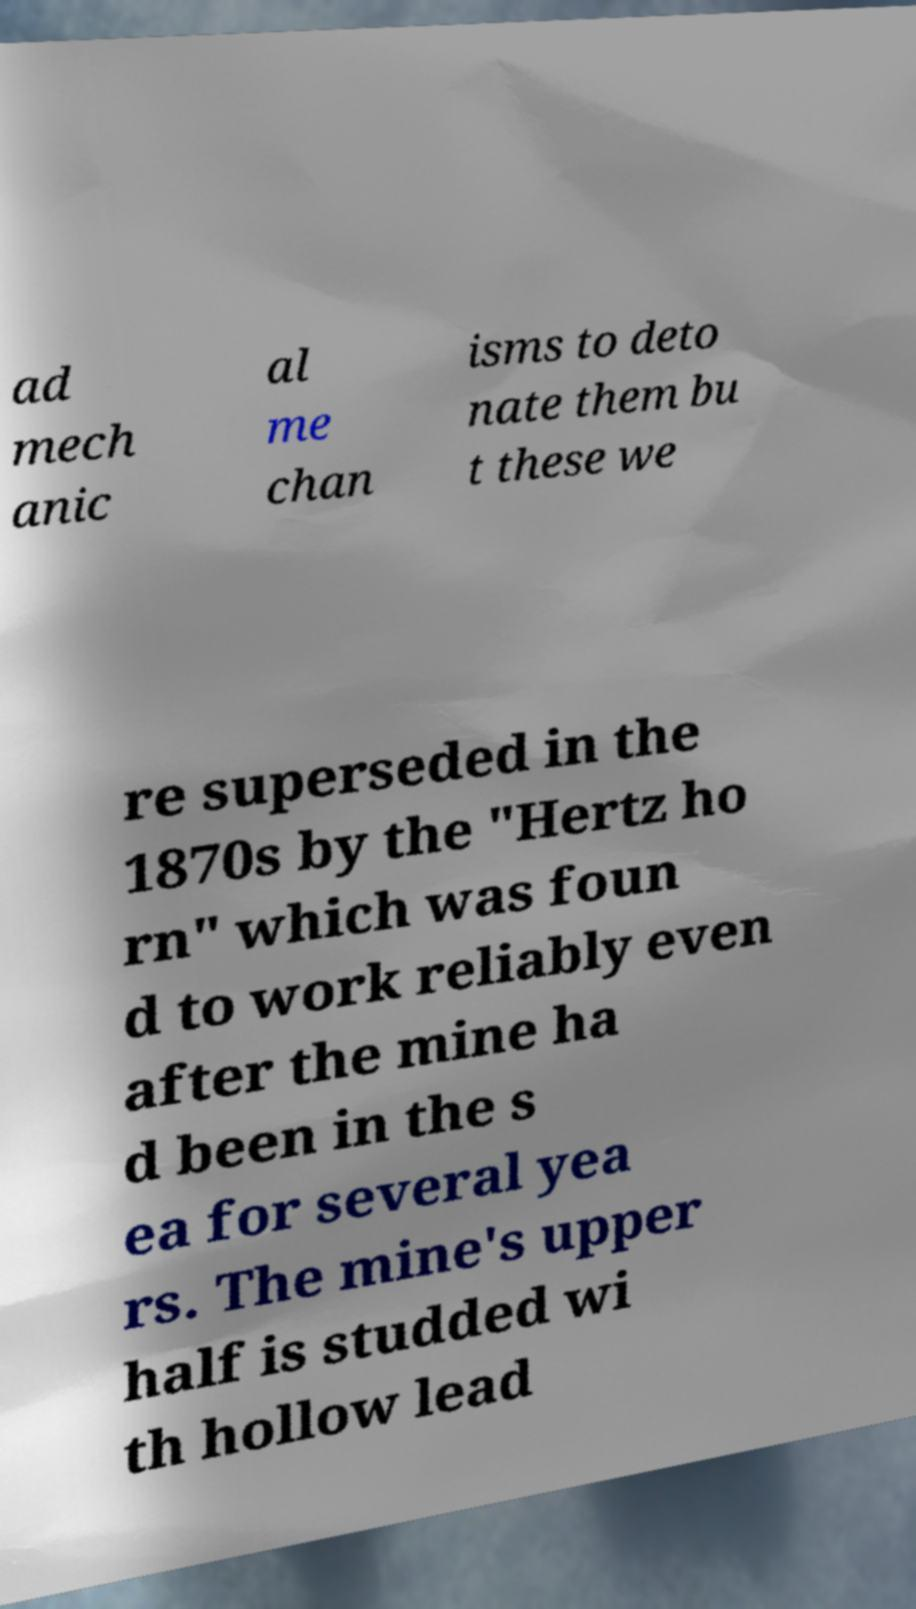I need the written content from this picture converted into text. Can you do that? ad mech anic al me chan isms to deto nate them bu t these we re superseded in the 1870s by the "Hertz ho rn" which was foun d to work reliably even after the mine ha d been in the s ea for several yea rs. The mine's upper half is studded wi th hollow lead 